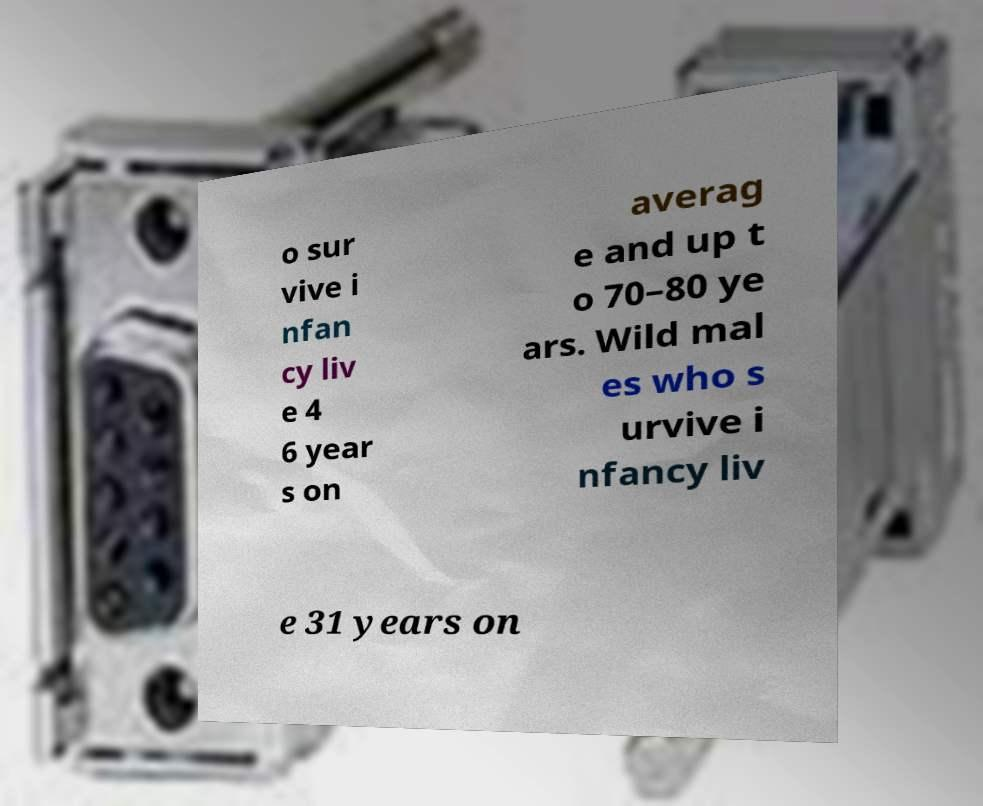Can you read and provide the text displayed in the image?This photo seems to have some interesting text. Can you extract and type it out for me? o sur vive i nfan cy liv e 4 6 year s on averag e and up t o 70–80 ye ars. Wild mal es who s urvive i nfancy liv e 31 years on 